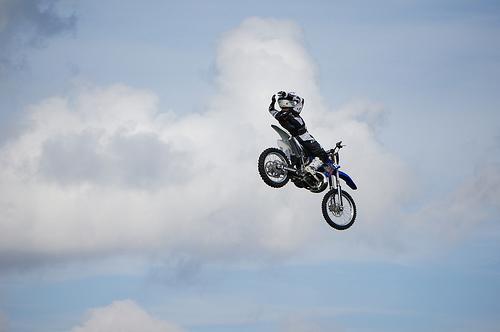How many people are there?
Give a very brief answer. 1. How many birds are to the left?
Give a very brief answer. 0. 